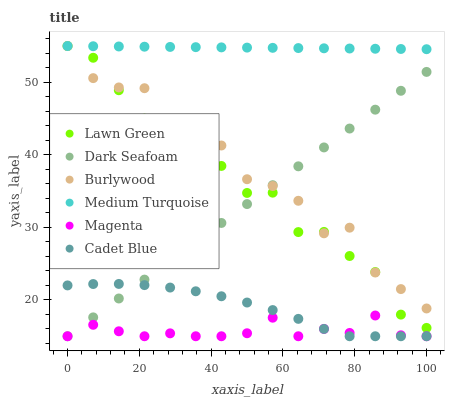Does Magenta have the minimum area under the curve?
Answer yes or no. Yes. Does Medium Turquoise have the maximum area under the curve?
Answer yes or no. Yes. Does Cadet Blue have the minimum area under the curve?
Answer yes or no. No. Does Cadet Blue have the maximum area under the curve?
Answer yes or no. No. Is Medium Turquoise the smoothest?
Answer yes or no. Yes. Is Burlywood the roughest?
Answer yes or no. Yes. Is Cadet Blue the smoothest?
Answer yes or no. No. Is Cadet Blue the roughest?
Answer yes or no. No. Does Cadet Blue have the lowest value?
Answer yes or no. Yes. Does Burlywood have the lowest value?
Answer yes or no. No. Does Medium Turquoise have the highest value?
Answer yes or no. Yes. Does Cadet Blue have the highest value?
Answer yes or no. No. Is Cadet Blue less than Medium Turquoise?
Answer yes or no. Yes. Is Medium Turquoise greater than Magenta?
Answer yes or no. Yes. Does Cadet Blue intersect Magenta?
Answer yes or no. Yes. Is Cadet Blue less than Magenta?
Answer yes or no. No. Is Cadet Blue greater than Magenta?
Answer yes or no. No. Does Cadet Blue intersect Medium Turquoise?
Answer yes or no. No. 